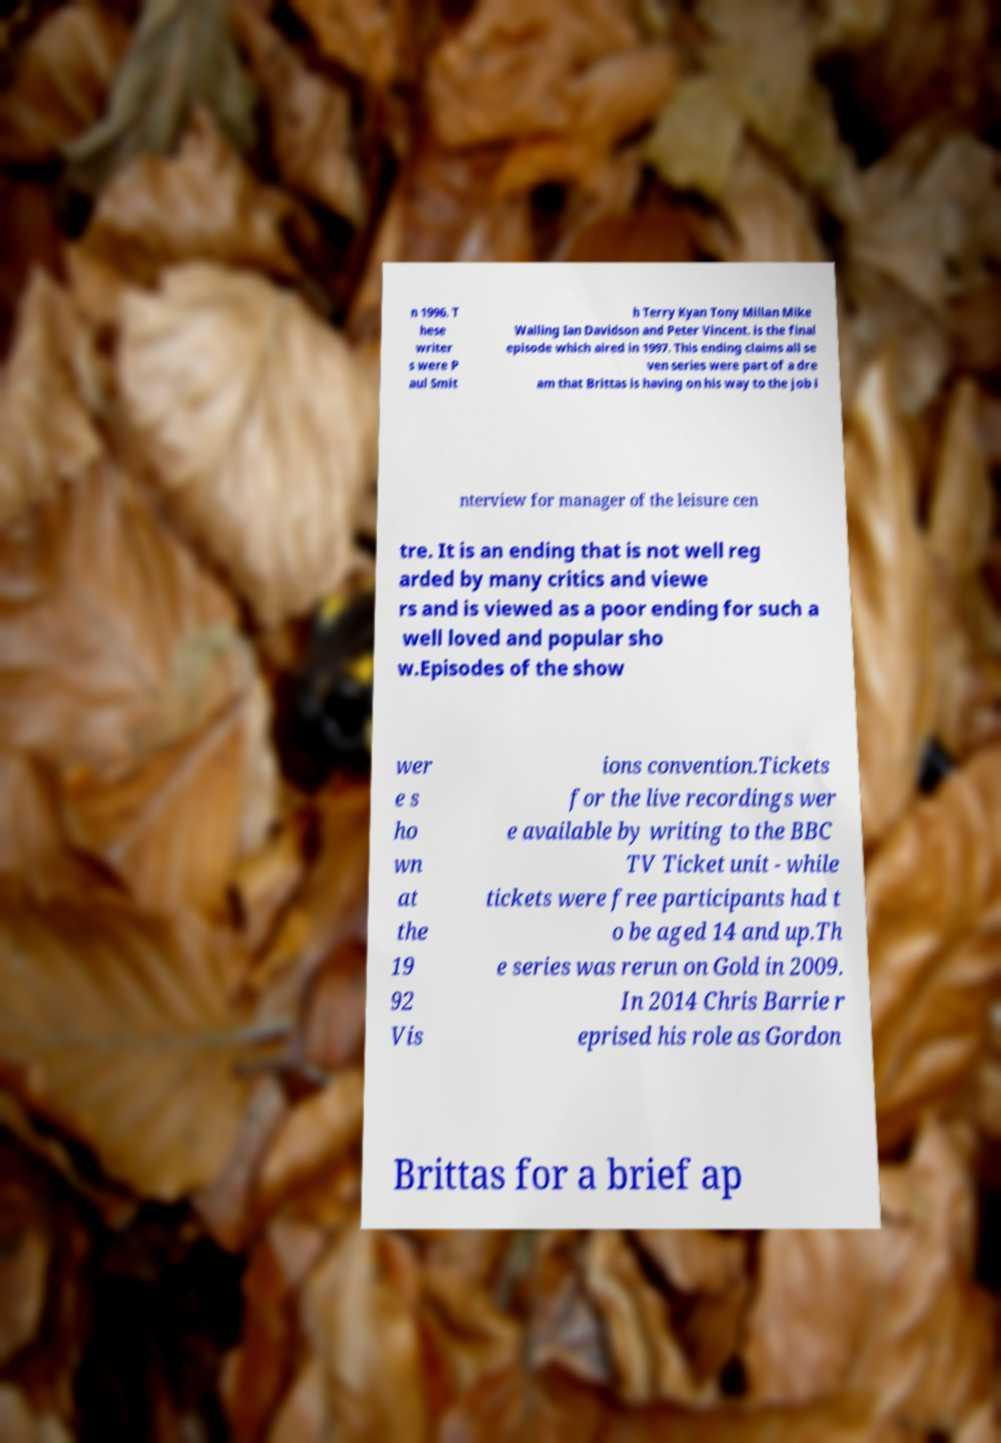Could you extract and type out the text from this image? n 1996. T hese writer s were P aul Smit h Terry Kyan Tony Millan Mike Walling Ian Davidson and Peter Vincent. is the final episode which aired in 1997. This ending claims all se ven series were part of a dre am that Brittas is having on his way to the job i nterview for manager of the leisure cen tre. It is an ending that is not well reg arded by many critics and viewe rs and is viewed as a poor ending for such a well loved and popular sho w.Episodes of the show wer e s ho wn at the 19 92 Vis ions convention.Tickets for the live recordings wer e available by writing to the BBC TV Ticket unit - while tickets were free participants had t o be aged 14 and up.Th e series was rerun on Gold in 2009. In 2014 Chris Barrie r eprised his role as Gordon Brittas for a brief ap 